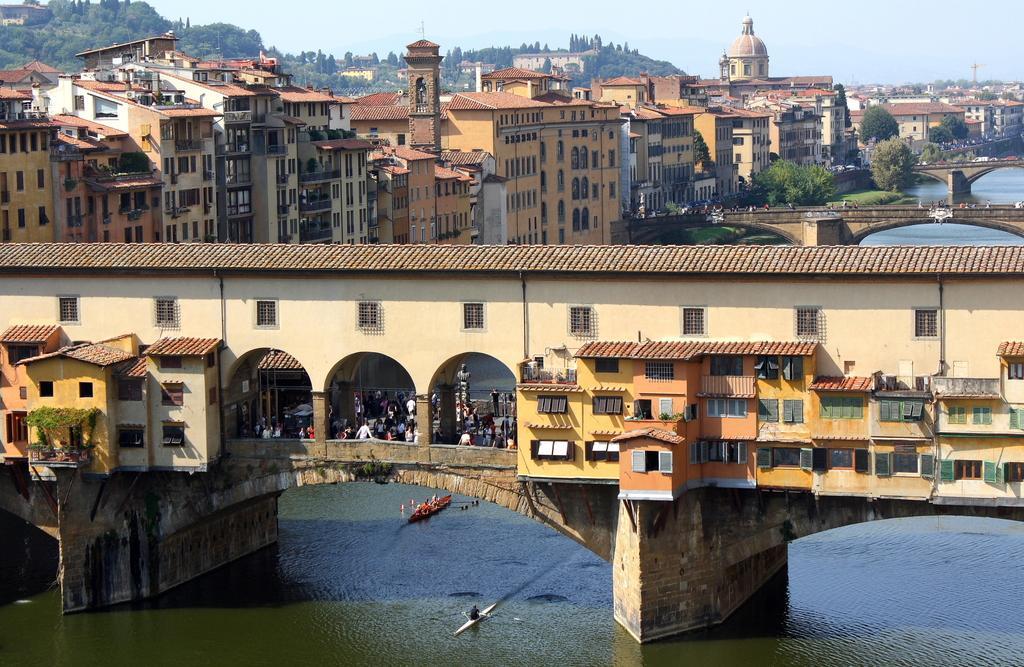Describe this image in one or two sentences. In this image we can see the bridge with the buildings. We can also see the people. In the background we can see many buildings, trees, hill and also the bridges. We can also see the sky. At the bottom we can see the boats on the surface of the water. 